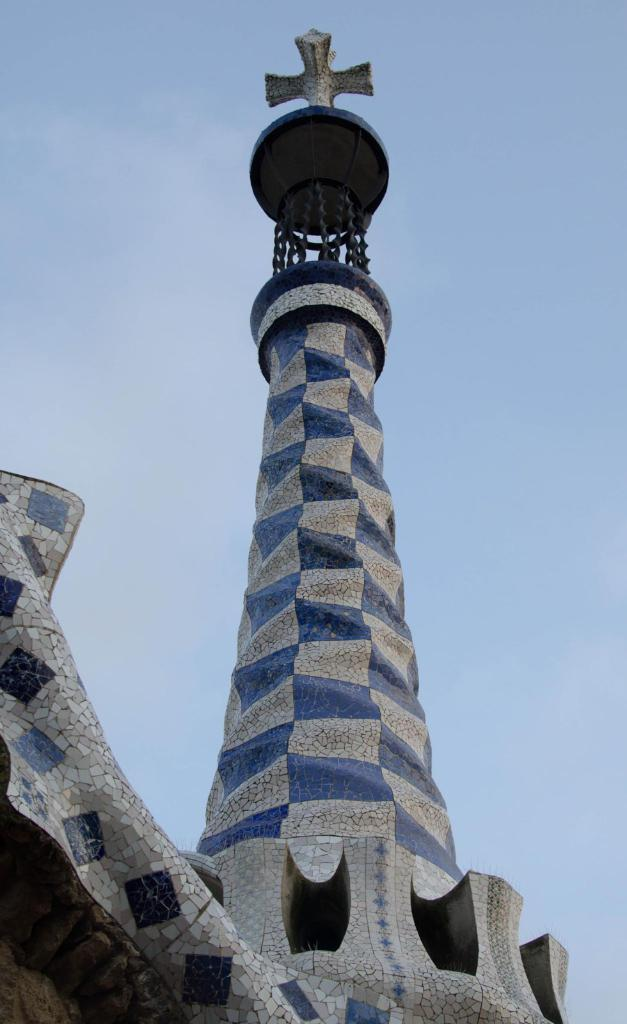What type of structure is present in the image? There is a building in the image. What can be seen on top of the building? There is a cross on top of the building. What is visible in the background of the image? The sky is visible in the background of the image. What type of coat is being worn by the army in the image? There is no army or coat present in the image. The image only features a building with a cross on top and a visible sky in the background. 